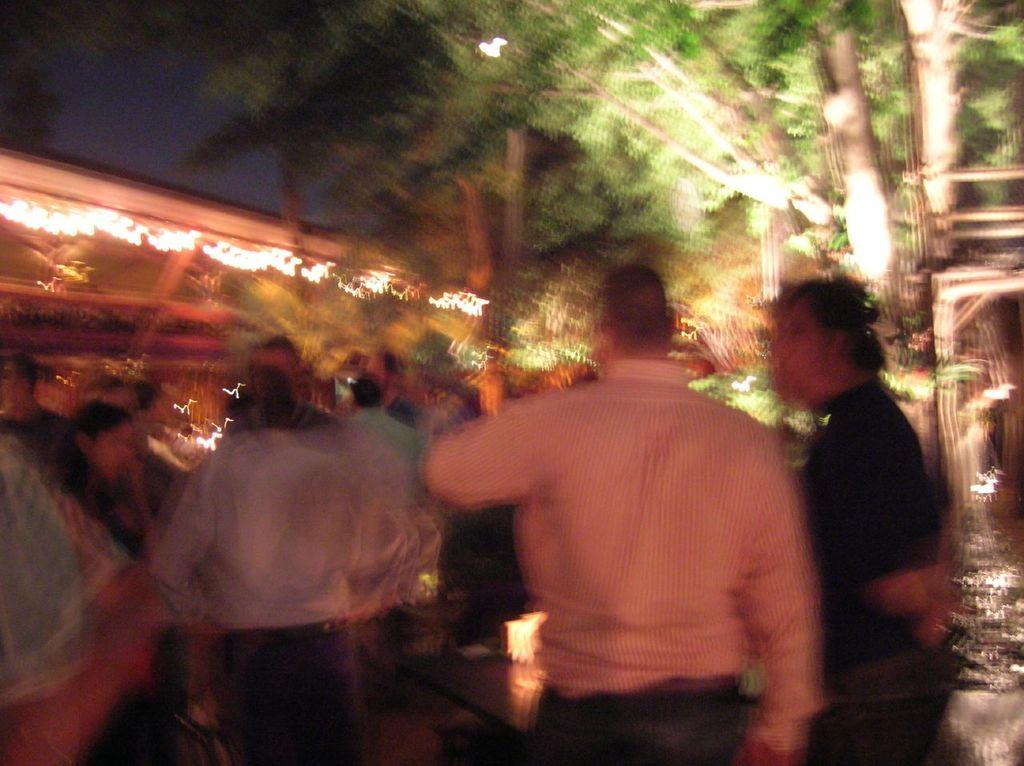What is the main subject of the image? There is a group of people in the image. What can be seen in the background of the image? There are trees in the image. Are there any artificial light sources visible in the image? Yes, there are lights in the image. What part of the sky is visible in the image? The sky is visible at the top left corner of the image. What type of bat is flying in the image? There is no bat present in the image. What is the plot of the story unfolding in the image? The image does not depict a story or plot; it is a static scene of a group of people, trees, lights, and a portion of the sky. 